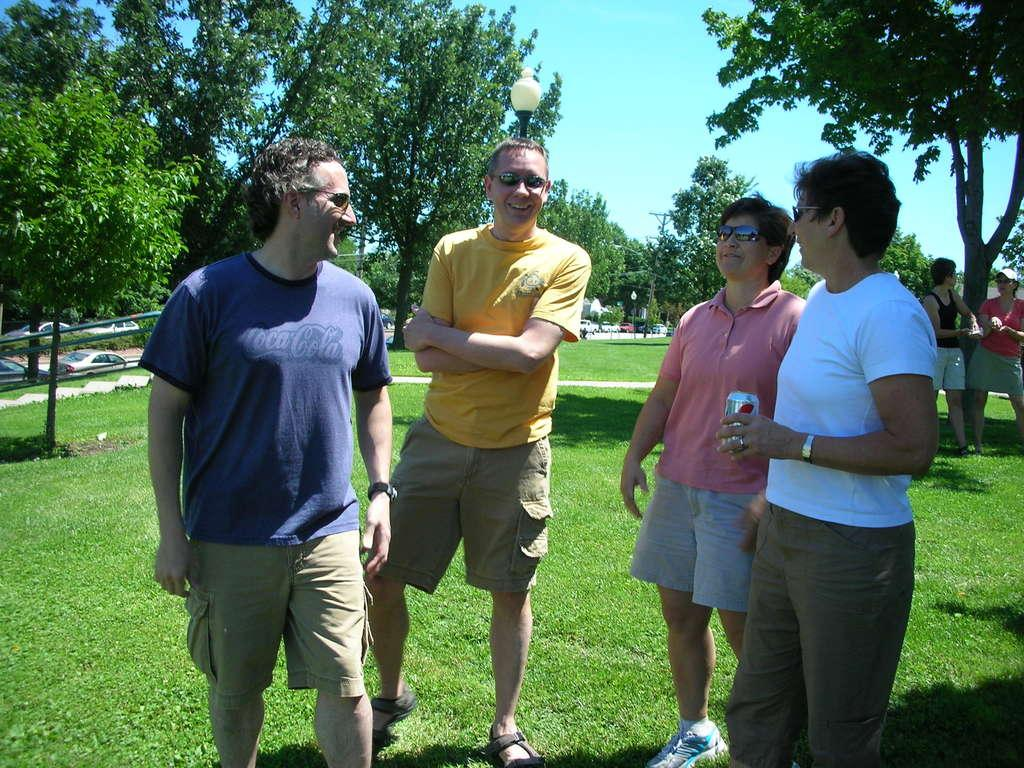What are the people in the image doing? The people are standing in the image. Where are the people located? The people are in a garden. What can be seen in the background of the image? There are trees, light poles, and the sky visible in the background of the image. What type of furniture is present in the image? There is no furniture present in the image; it features people standing in a garden. What is the condition of the grass in the image? The provided facts do not mention the condition of the grass, so it cannot be determined from the image. 